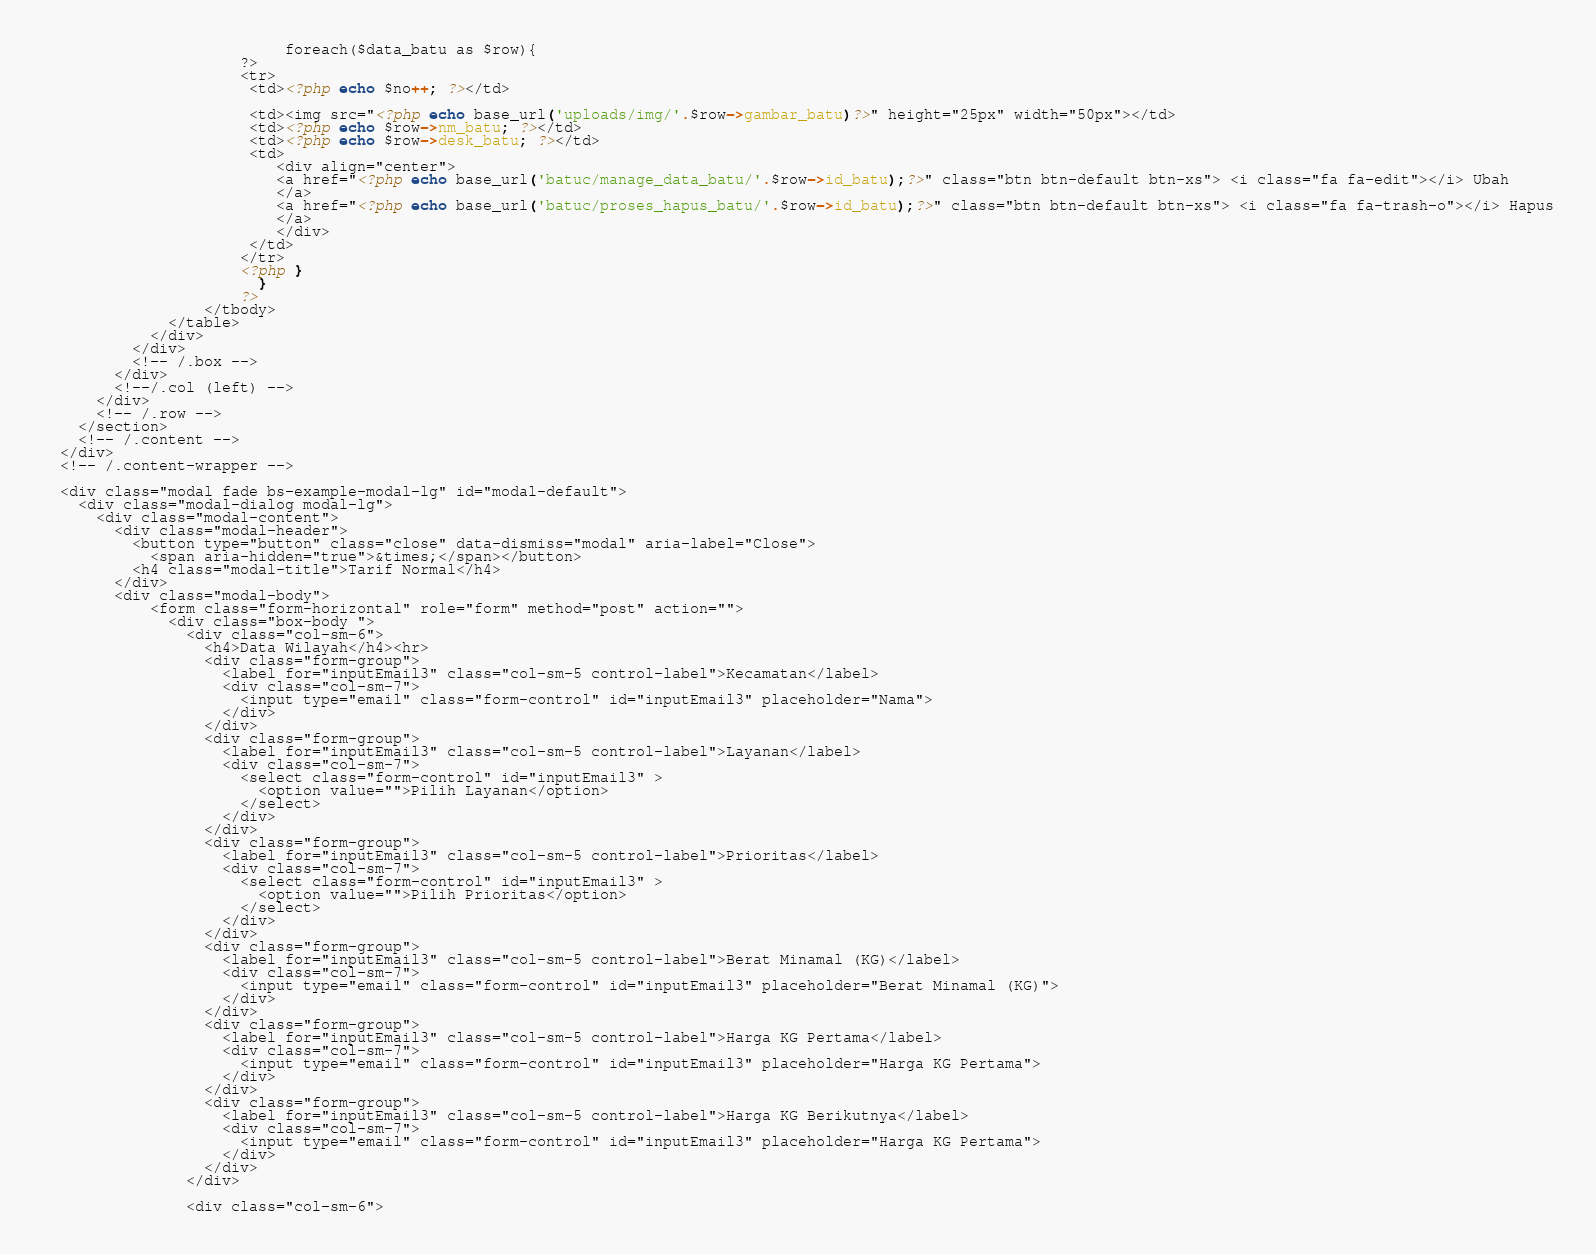<code> <loc_0><loc_0><loc_500><loc_500><_PHP_>                           foreach($data_batu as $row){
                      ?>
                      <tr>
                       <td><?php echo $no++; ?></td>

                       <td><img src="<?php echo base_url('uploads/img/'.$row->gambar_batu)?>" height="25px" width="50px"></td>
                       <td><?php echo $row->nm_batu; ?></td>
                       <td><?php echo $row->desk_batu; ?></td>
                       <td>
                          <div align="center">
                          <a href="<?php echo base_url('batuc/manage_data_batu/'.$row->id_batu);?>" class="btn btn-default btn-xs"> <i class="fa fa-edit"></i> Ubah
                          </a>
                          <a href="<?php echo base_url('batuc/proses_hapus_batu/'.$row->id_batu);?>" class="btn btn-default btn-xs"> <i class="fa fa-trash-o"></i> Hapus
                          </a>
                          </div>
                       </td>
                      </tr>
                      <?php }
                        }
                      ?>
                  </tbody>
              </table>
            </div>
          </div>
          <!-- /.box -->
        </div>
        <!--/.col (left) -->
      </div>
      <!-- /.row -->
    </section>
    <!-- /.content -->
  </div>
  <!-- /.content-wrapper -->

  <div class="modal fade bs-example-modal-lg" id="modal-default">
    <div class="modal-dialog modal-lg">
      <div class="modal-content">
        <div class="modal-header">
          <button type="button" class="close" data-dismiss="modal" aria-label="Close">
            <span aria-hidden="true">&times;</span></button>
          <h4 class="modal-title">Tarif Normal</h4>
        </div>
        <div class="modal-body">
            <form class="form-horizontal" role="form" method="post" action="">
              <div class="box-body ">
                <div class="col-sm-6">
                  <h4>Data Wilayah</h4><hr>
                  <div class="form-group">
                    <label for="inputEmail3" class="col-sm-5 control-label">Kecamatan</label>
                    <div class="col-sm-7">
                      <input type="email" class="form-control" id="inputEmail3" placeholder="Nama">
                    </div>
                  </div>
                  <div class="form-group">
                    <label for="inputEmail3" class="col-sm-5 control-label">Layanan</label>
                    <div class="col-sm-7">
                      <select class="form-control" id="inputEmail3" >
                        <option value="">Pilih Layanan</option>
                      </select>
                    </div>
                  </div>
                  <div class="form-group">
                    <label for="inputEmail3" class="col-sm-5 control-label">Prioritas</label>
                    <div class="col-sm-7">
                      <select class="form-control" id="inputEmail3" >
                        <option value="">Pilih Prioritas</option>
                      </select>
                    </div>
                  </div>
                  <div class="form-group">
                    <label for="inputEmail3" class="col-sm-5 control-label">Berat Minamal (KG)</label>
                    <div class="col-sm-7">
                      <input type="email" class="form-control" id="inputEmail3" placeholder="Berat Minamal (KG)">
                    </div>
                  </div>
                  <div class="form-group">
                    <label for="inputEmail3" class="col-sm-5 control-label">Harga KG Pertama</label>
                    <div class="col-sm-7">
                      <input type="email" class="form-control" id="inputEmail3" placeholder="Harga KG Pertama">
                    </div>
                  </div>
                  <div class="form-group">
                    <label for="inputEmail3" class="col-sm-5 control-label">Harga KG Berikutnya</label>
                    <div class="col-sm-7">
                      <input type="email" class="form-control" id="inputEmail3" placeholder="Harga KG Pertama">
                    </div>
                  </div>
                </div>

                <div class="col-sm-6"></code> 